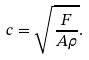<formula> <loc_0><loc_0><loc_500><loc_500>c = \sqrt { \frac { F } { A \rho } } .</formula> 